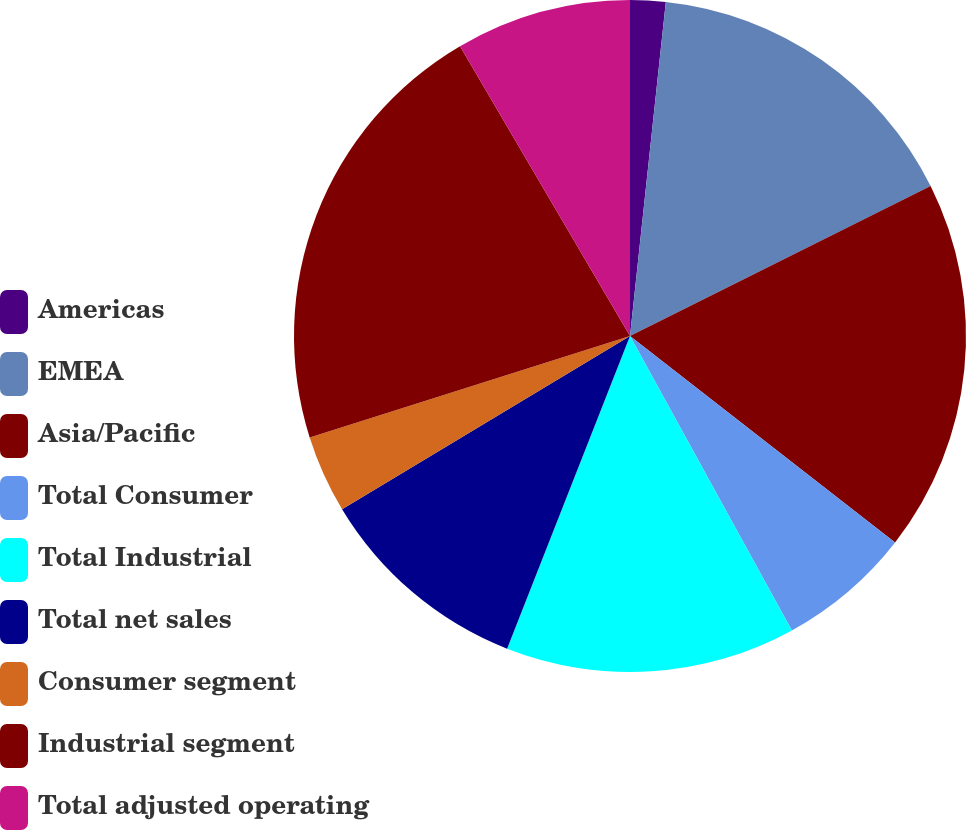Convert chart. <chart><loc_0><loc_0><loc_500><loc_500><pie_chart><fcel>Americas<fcel>EMEA<fcel>Asia/Pacific<fcel>Total Consumer<fcel>Total Industrial<fcel>Total net sales<fcel>Consumer segment<fcel>Industrial segment<fcel>Total adjusted operating<nl><fcel>1.7%<fcel>15.93%<fcel>17.9%<fcel>6.47%<fcel>13.96%<fcel>10.42%<fcel>3.74%<fcel>21.44%<fcel>8.44%<nl></chart> 